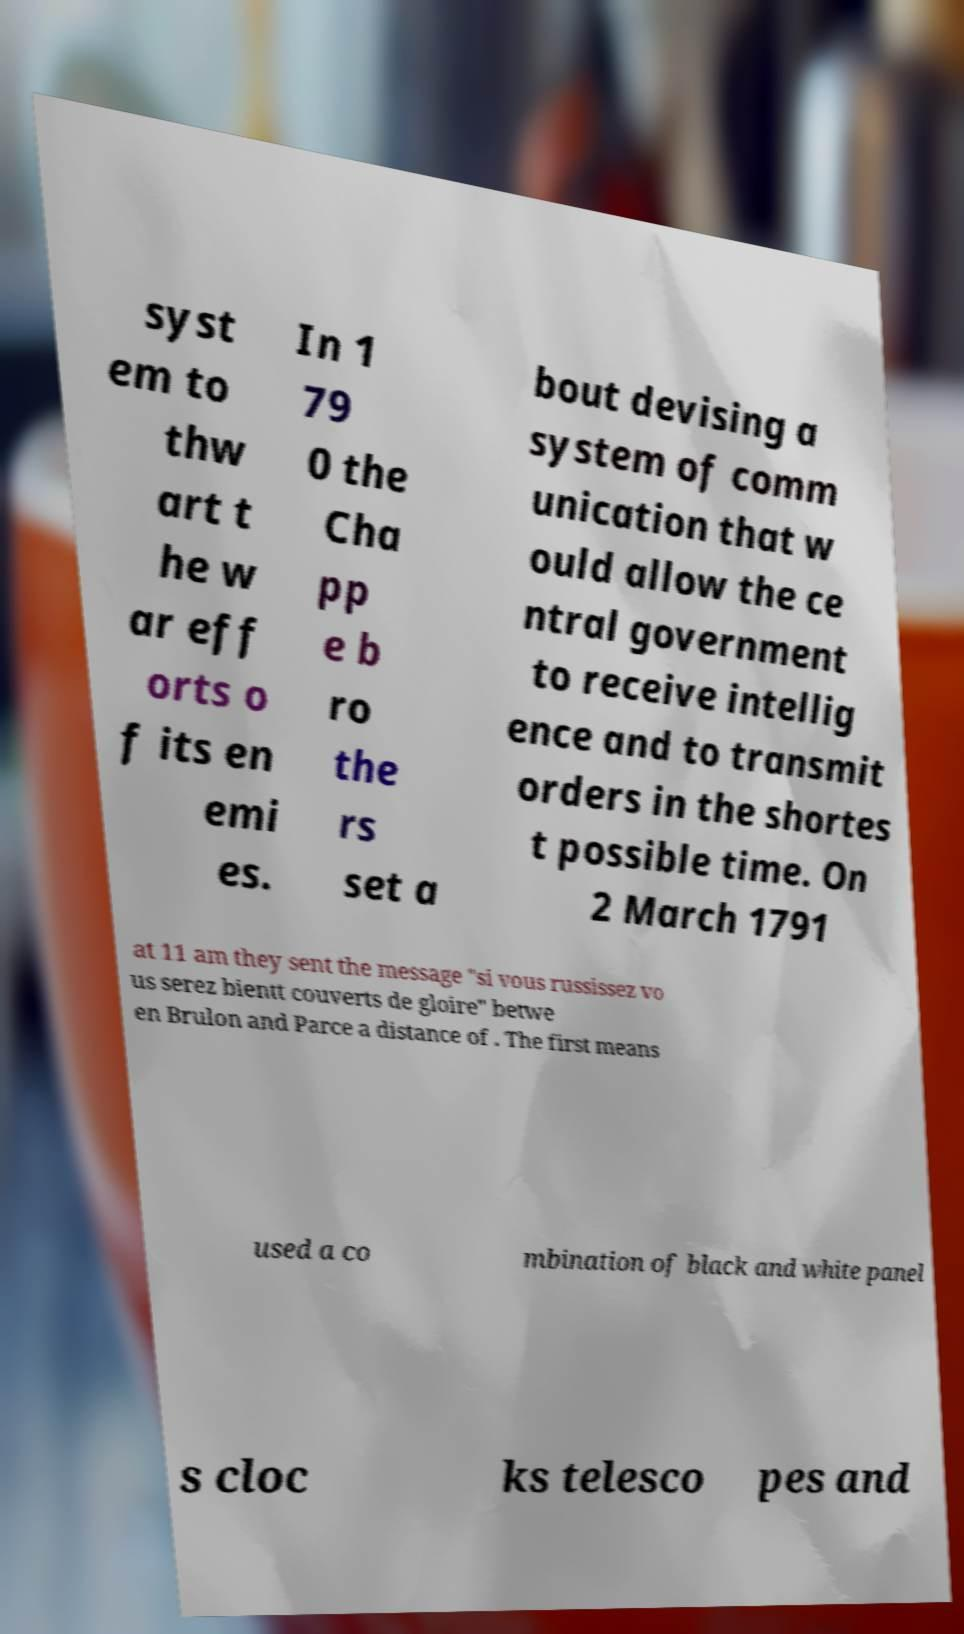For documentation purposes, I need the text within this image transcribed. Could you provide that? syst em to thw art t he w ar eff orts o f its en emi es. In 1 79 0 the Cha pp e b ro the rs set a bout devising a system of comm unication that w ould allow the ce ntral government to receive intellig ence and to transmit orders in the shortes t possible time. On 2 March 1791 at 11 am they sent the message "si vous russissez vo us serez bientt couverts de gloire" betwe en Brulon and Parce a distance of . The first means used a co mbination of black and white panel s cloc ks telesco pes and 